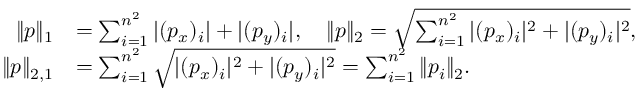Convert formula to latex. <formula><loc_0><loc_0><loc_500><loc_500>\begin{array} { r l } { \| p \| _ { 1 } } & { = \sum _ { i = 1 } ^ { n ^ { 2 } } | ( p _ { x } ) _ { i } | + | ( p _ { y } ) _ { i } | , \quad \| p \| _ { 2 } = \sqrt { \sum _ { i = 1 } ^ { n ^ { 2 } } | ( p _ { x } ) _ { i } | ^ { 2 } + | ( p _ { y } ) _ { i } | ^ { 2 } } , } \\ { \| p \| _ { 2 , 1 } } & { = \sum _ { i = 1 } ^ { n ^ { 2 } } \sqrt { | ( p _ { x } ) _ { i } | ^ { 2 } + | ( p _ { y } ) _ { i } | ^ { 2 } } = \sum _ { i = 1 } ^ { n ^ { 2 } } \| p _ { i } \| _ { 2 } . } \end{array}</formula> 